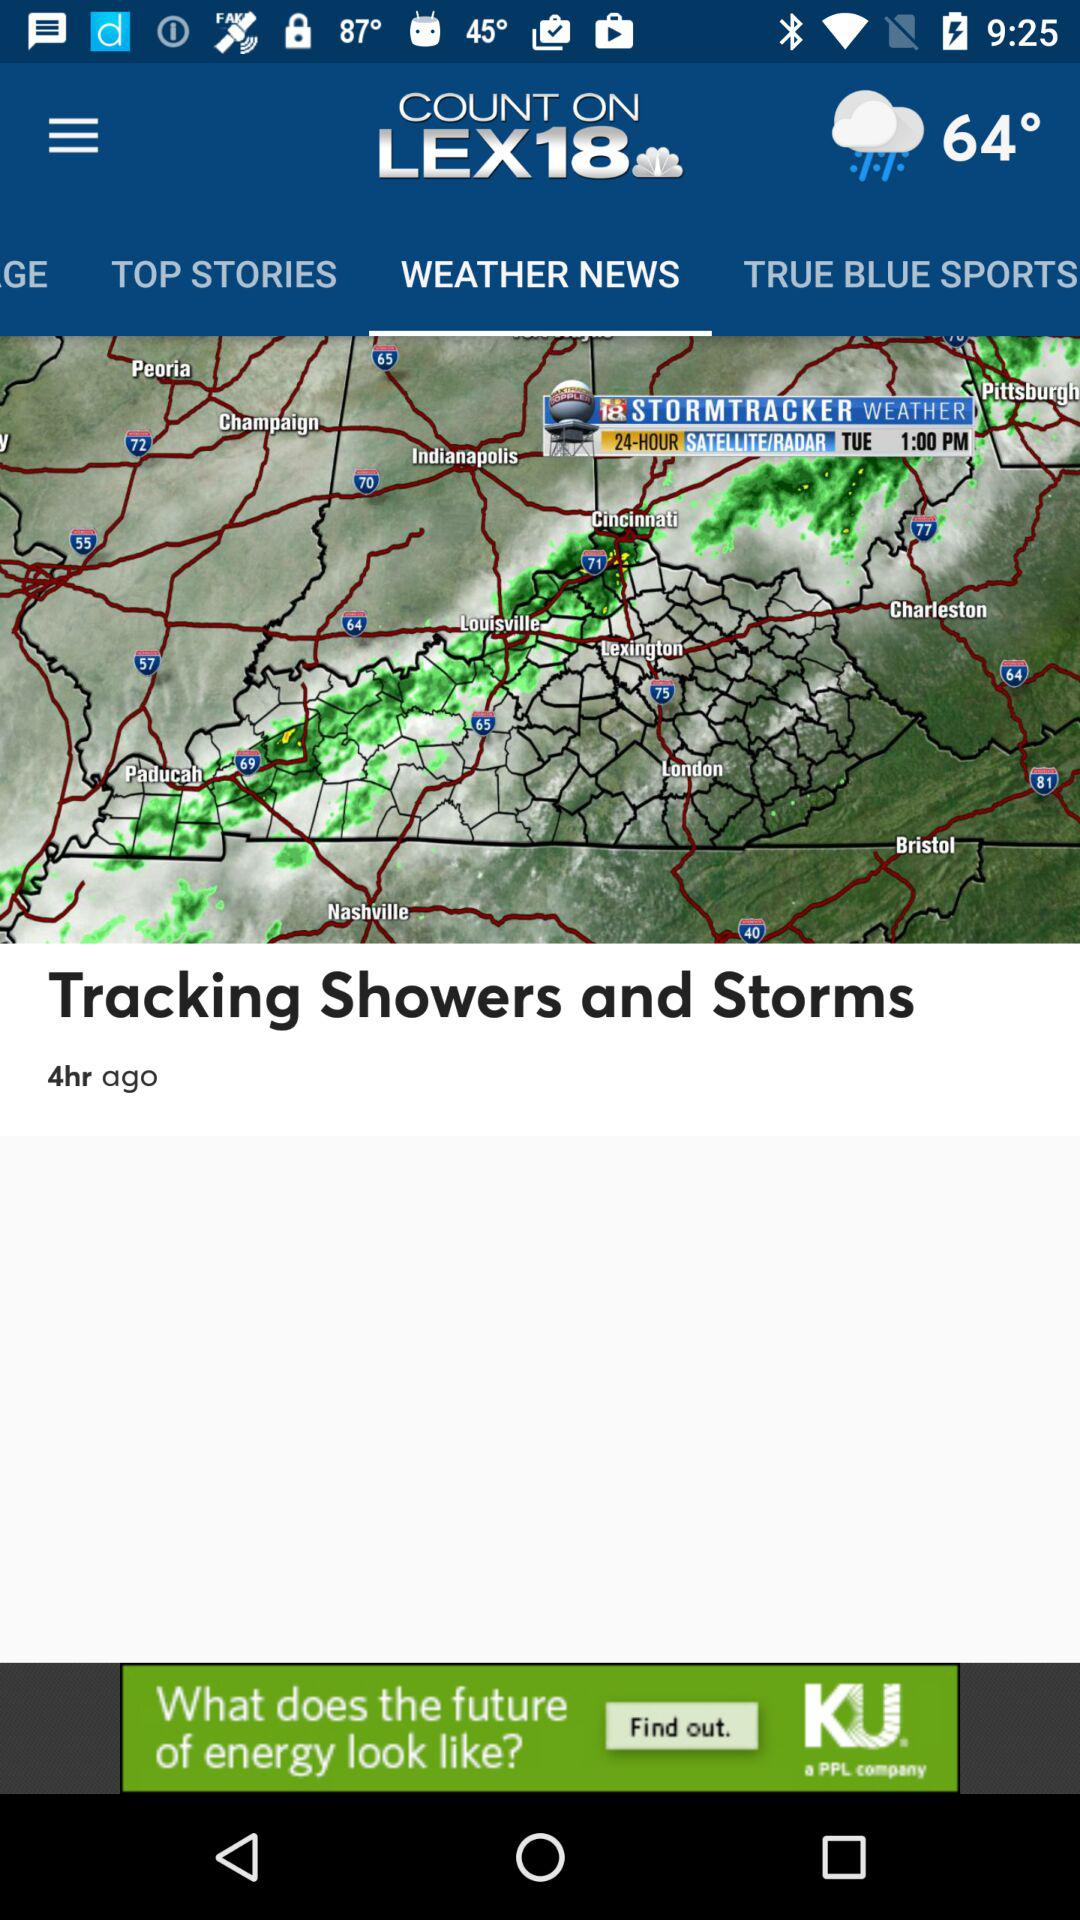How many top stories are there?
When the provided information is insufficient, respond with <no answer>. <no answer> 